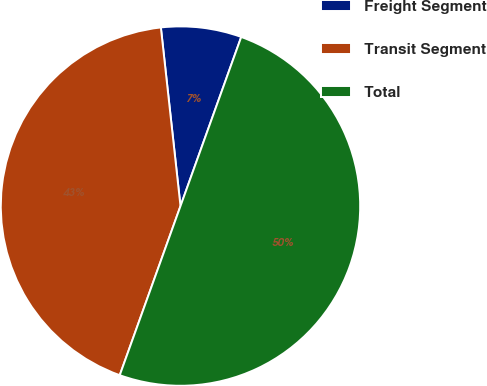<chart> <loc_0><loc_0><loc_500><loc_500><pie_chart><fcel>Freight Segment<fcel>Transit Segment<fcel>Total<nl><fcel>7.23%<fcel>42.77%<fcel>50.0%<nl></chart> 